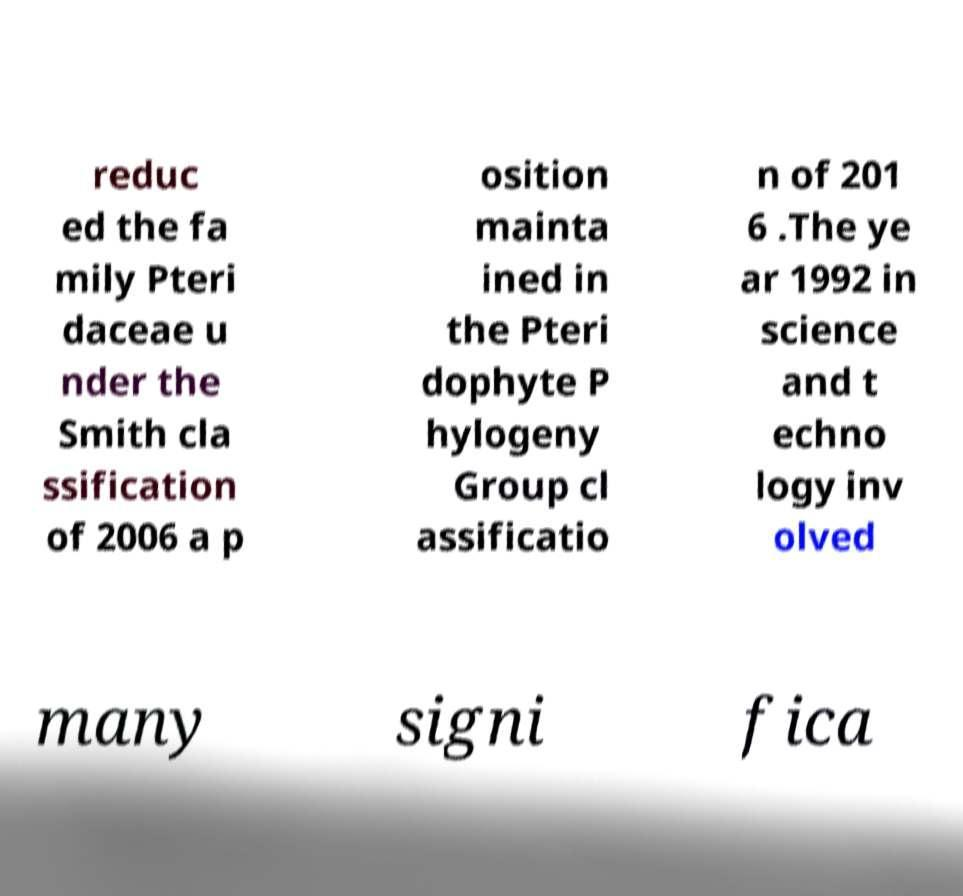Please read and relay the text visible in this image. What does it say? reduc ed the fa mily Pteri daceae u nder the Smith cla ssification of 2006 a p osition mainta ined in the Pteri dophyte P hylogeny Group cl assificatio n of 201 6 .The ye ar 1992 in science and t echno logy inv olved many signi fica 